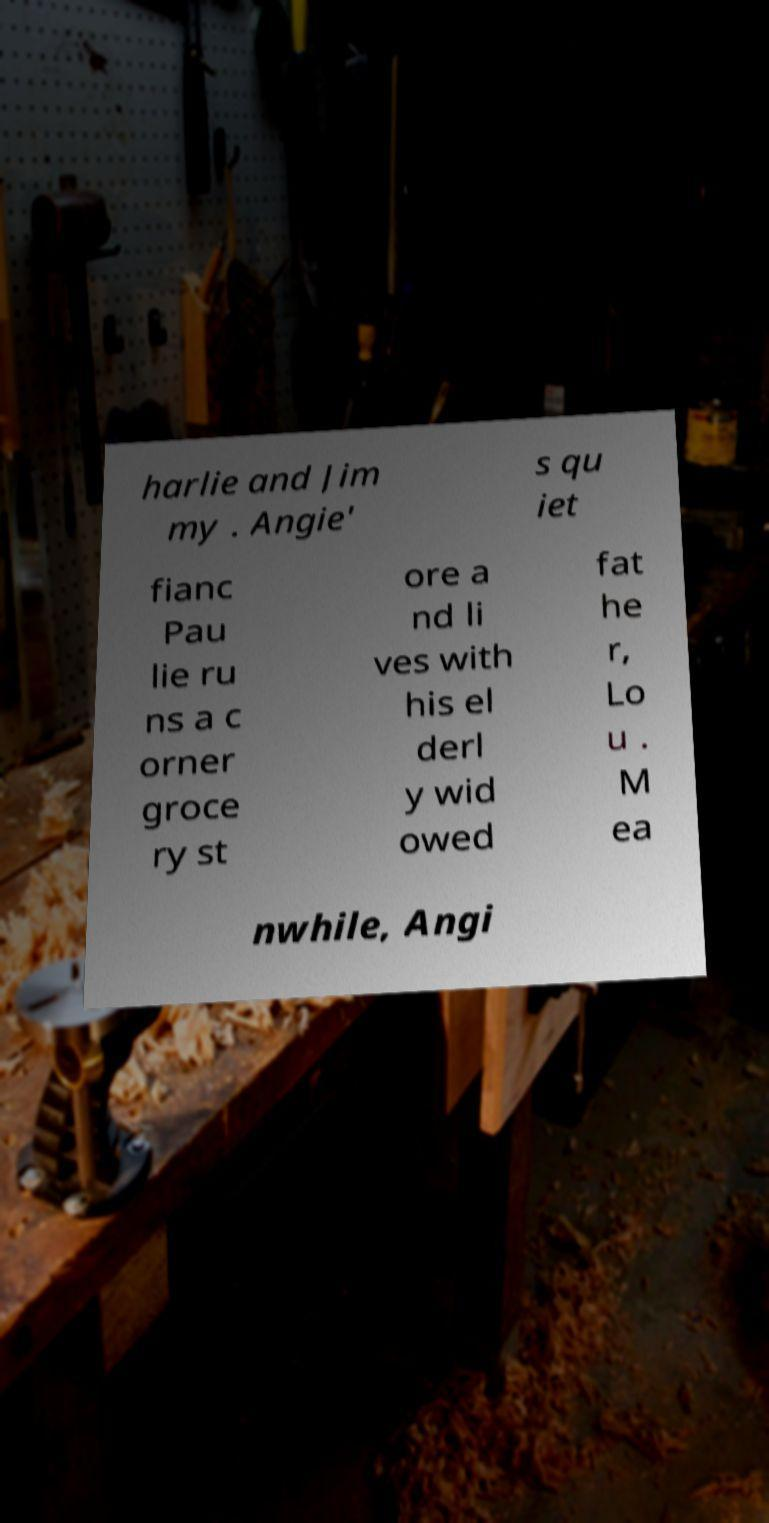Please read and relay the text visible in this image. What does it say? harlie and Jim my . Angie' s qu iet fianc Pau lie ru ns a c orner groce ry st ore a nd li ves with his el derl y wid owed fat he r, Lo u . M ea nwhile, Angi 